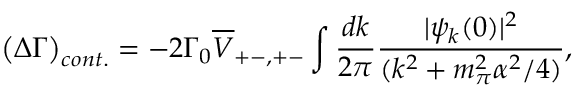Convert formula to latex. <formula><loc_0><loc_0><loc_500><loc_500>\left ( \Delta \Gamma \right ) _ { c o n t . } = - 2 \Gamma _ { 0 } \overline { V } _ { + - , + - } \int \frac { d k } { 2 \pi } \frac { | \psi _ { k } ( 0 ) | ^ { 2 } } { ( k ^ { 2 } + m _ { \pi } ^ { 2 } \alpha ^ { 2 } / 4 ) } ,</formula> 